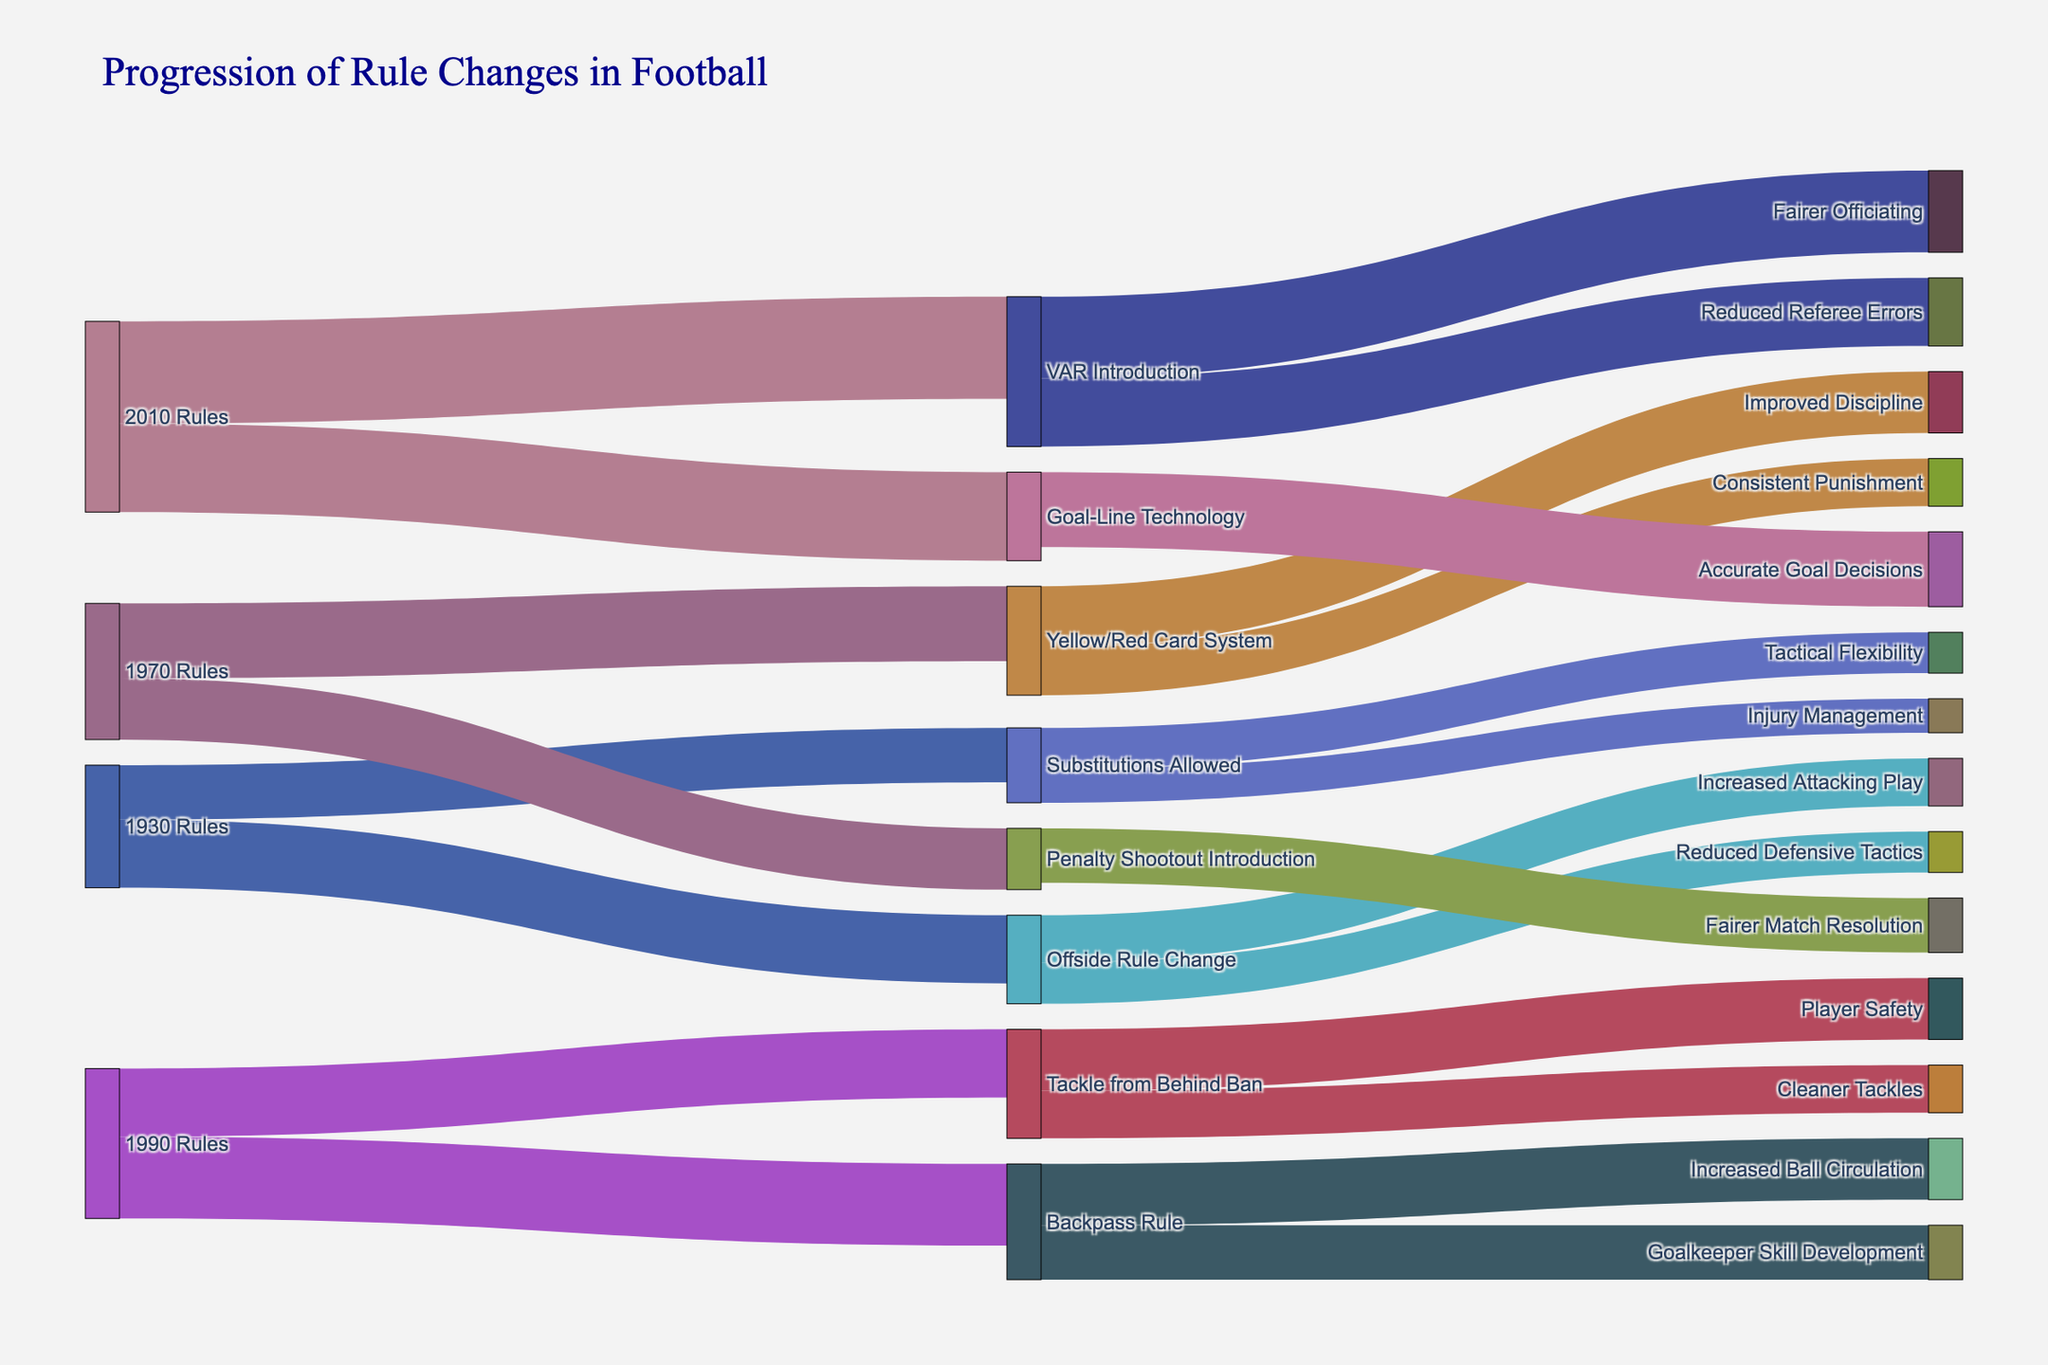What is the title of the visualization? The title of the visualization is directly shown at the top of the figure. It reads "Progression of Rule Changes in Football".
Answer: Progression of Rule Changes in Football Which rule change is associated with the highest value? Looking at the values shown on the links, the highest value is 15, and it is associated with the rule change "VAR Introduction".
Answer: VAR Introduction How many rule changes were introduced in the 1990 Rules? The category "1990 Rules" has two outgoing links indicating rule changes. These are "Backpass Rule" and "Tackle from Behind Ban".
Answer: 2 Which rule change in the 1970 Rules led to a fairer match resolution? From the links extending from "1970 Rules," the rule change leading to "Fairer Match Resolution" is "Penalty Shootout Introduction".
Answer: Penalty Shootout Introduction Compare the values of Increased Attacking Play and Injury Management. Which one is higher? The value associated with "Increased Attacking Play" is 7, and the value for "Injury Management" is 5. Hence, "Increased Attacking Play" is higher.
Answer: Increased Attacking Play What is the combined value of all impacts directly resulting from the 2010 Rules? From the 2010 Rules, the impacts are "Accurate Goal Decisions" (value 11), "Fairer Officiating" (value 12), and "Reduced Referee Errors" (value 10). The combined value is 11 + 12 + 10 = 33.
Answer: 33 Which pathway shows a focus on player safety? The pathway leading to "Player Safety" is from "Tackle from Behind Ban" which originates from the "1990 Rules".
Answer: Tackle from Behind Ban Is "Consistent Punishment" associated with a value higher or lower than "Goalkeeper Skill Development"? "Consistent Punishment" has a value of 7, whereas "Goalkeeper Skill Development" has a value of 8. Thus, "Consistent Punishment" is lower.
Answer: Lower What are the impacts of the Yellow/Red Card System? The impacts associated with the Yellow/Red Card System are "Improved Discipline" (value 9) and "Consistent Punishment" (value 7).
Answer: Improved Discipline, Consistent Punishment 